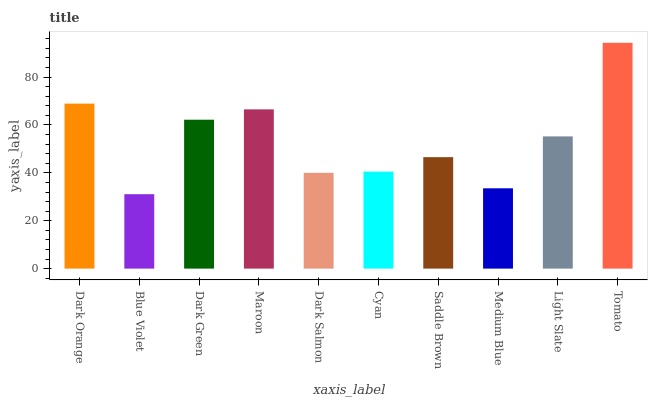Is Dark Green the minimum?
Answer yes or no. No. Is Dark Green the maximum?
Answer yes or no. No. Is Dark Green greater than Blue Violet?
Answer yes or no. Yes. Is Blue Violet less than Dark Green?
Answer yes or no. Yes. Is Blue Violet greater than Dark Green?
Answer yes or no. No. Is Dark Green less than Blue Violet?
Answer yes or no. No. Is Light Slate the high median?
Answer yes or no. Yes. Is Saddle Brown the low median?
Answer yes or no. Yes. Is Dark Orange the high median?
Answer yes or no. No. Is Tomato the low median?
Answer yes or no. No. 